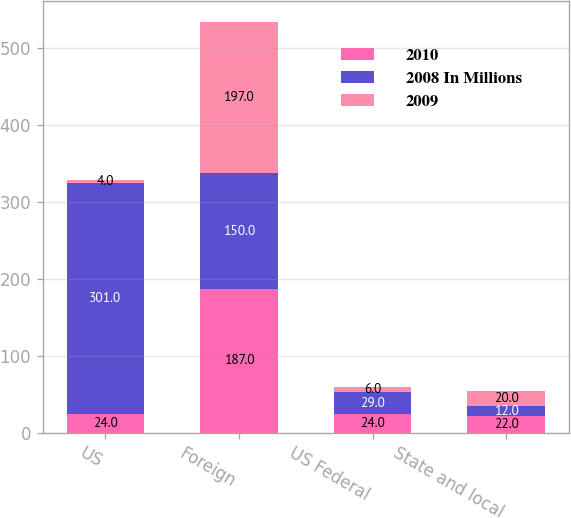Convert chart. <chart><loc_0><loc_0><loc_500><loc_500><stacked_bar_chart><ecel><fcel>US<fcel>Foreign<fcel>US Federal<fcel>State and local<nl><fcel>2010<fcel>24<fcel>187<fcel>24<fcel>22<nl><fcel>2008 In Millions<fcel>301<fcel>150<fcel>29<fcel>12<nl><fcel>2009<fcel>4<fcel>197<fcel>6<fcel>20<nl></chart> 